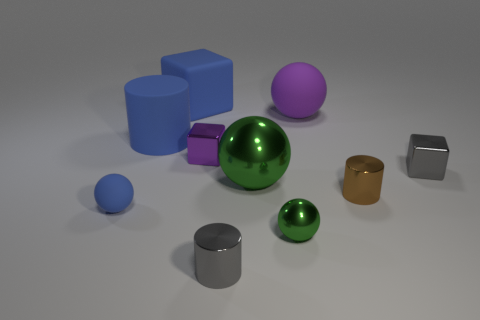Subtract all gray spheres. Subtract all blue cubes. How many spheres are left? 4 Subtract all spheres. How many objects are left? 6 Subtract all large rubber cylinders. Subtract all metallic cylinders. How many objects are left? 7 Add 8 tiny gray shiny objects. How many tiny gray shiny objects are left? 10 Add 3 gray cubes. How many gray cubes exist? 4 Subtract 0 gray balls. How many objects are left? 10 